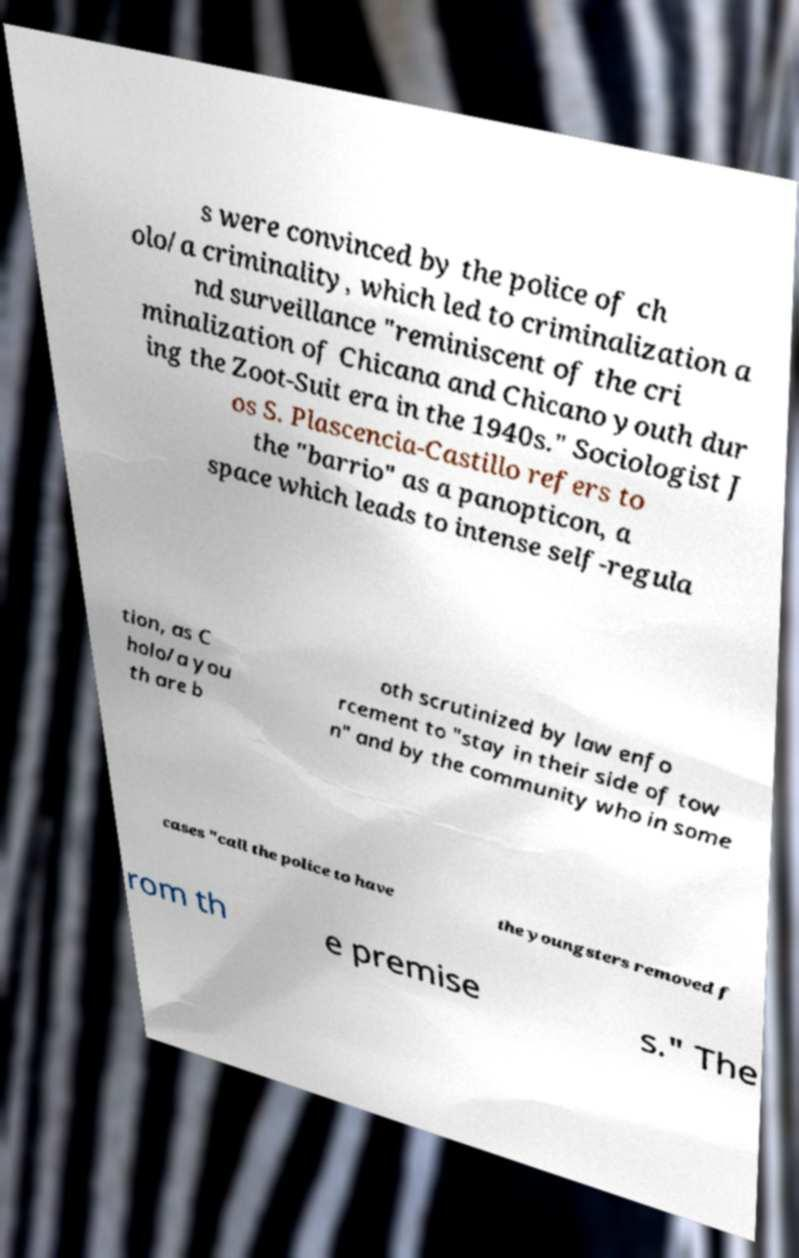Could you assist in decoding the text presented in this image and type it out clearly? s were convinced by the police of ch olo/a criminality, which led to criminalization a nd surveillance "reminiscent of the cri minalization of Chicana and Chicano youth dur ing the Zoot-Suit era in the 1940s." Sociologist J os S. Plascencia-Castillo refers to the "barrio" as a panopticon, a space which leads to intense self-regula tion, as C holo/a you th are b oth scrutinized by law enfo rcement to "stay in their side of tow n" and by the community who in some cases "call the police to have the youngsters removed f rom th e premise s." The 